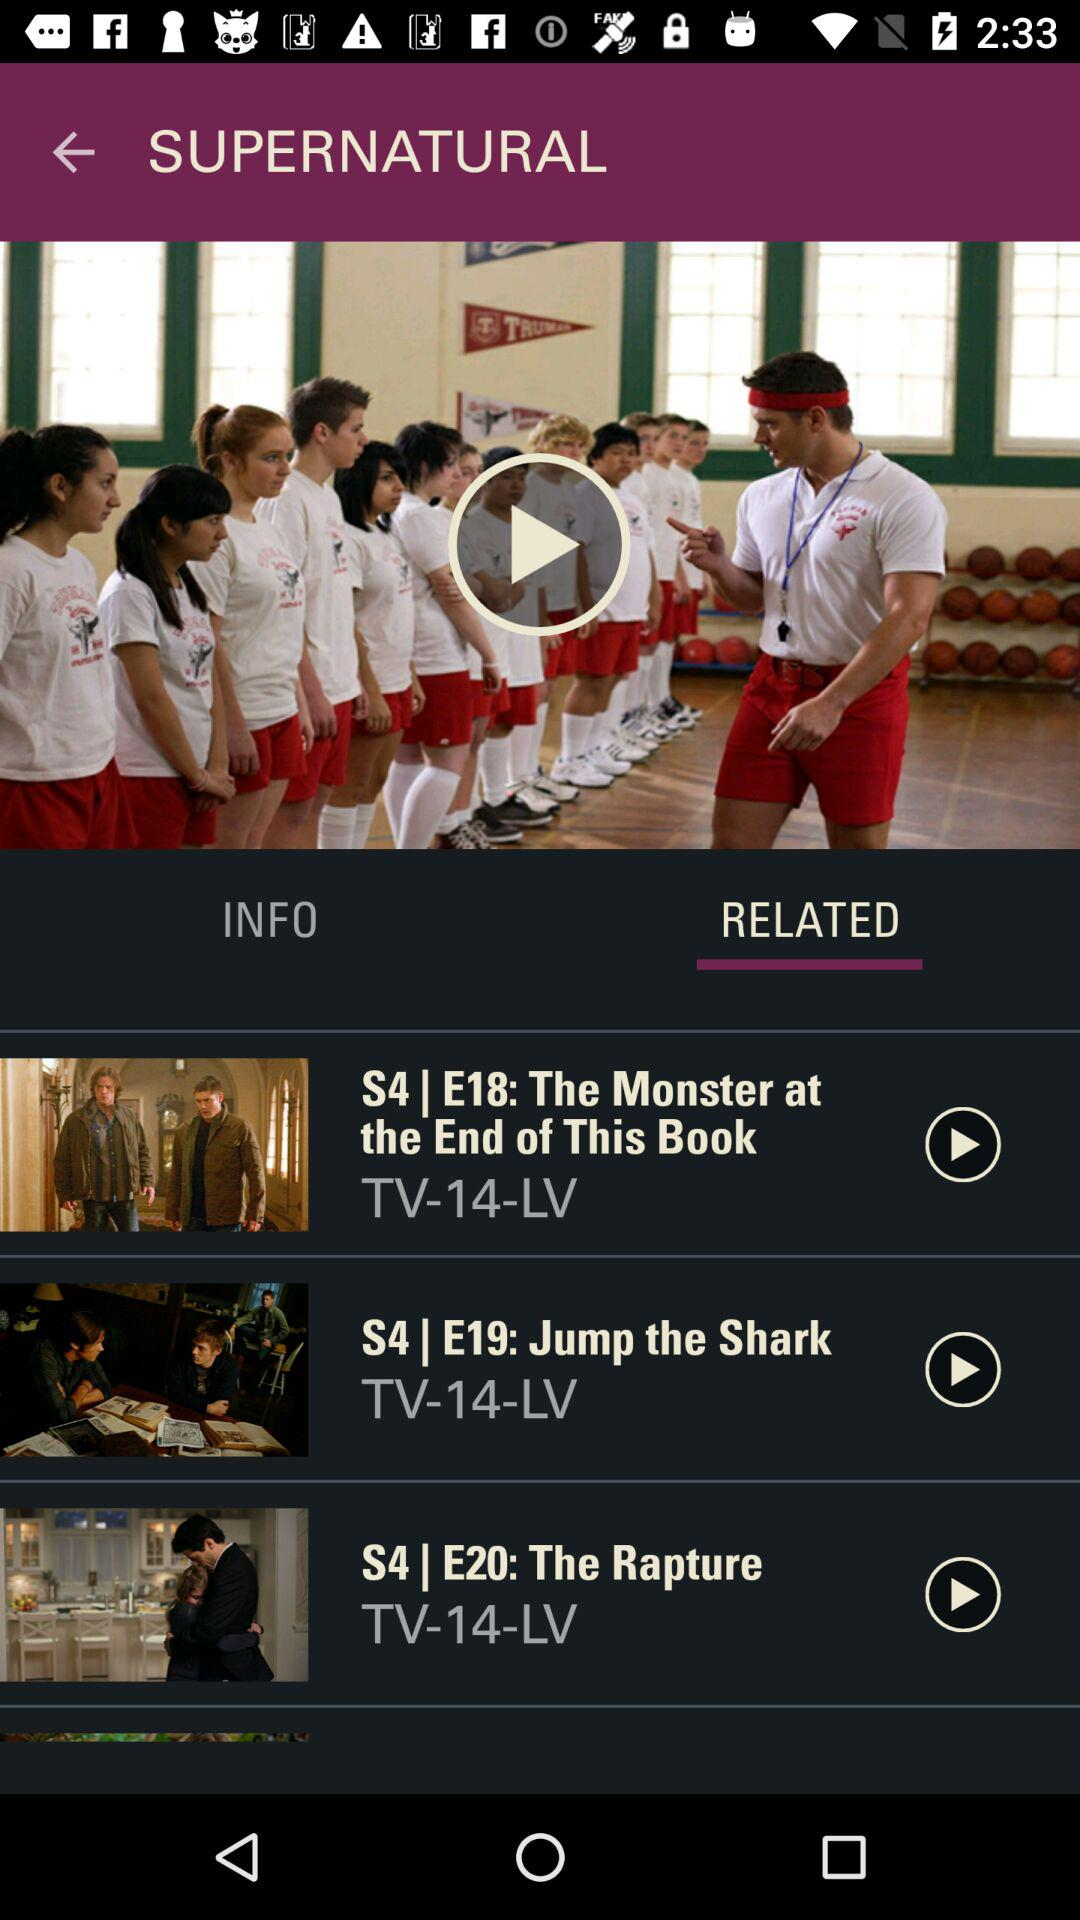What is the episode number of "The Rapture"? The episode number of "The Rapture" is 20. 